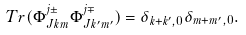<formula> <loc_0><loc_0><loc_500><loc_500>T r ( \Phi _ { J k m } ^ { j \pm } \Phi _ { J k ^ { \prime } m ^ { \prime } } ^ { j \mp } ) = \delta _ { { k + k ^ { \prime } } , 0 } \delta _ { m + m ^ { \prime } , 0 } .</formula> 